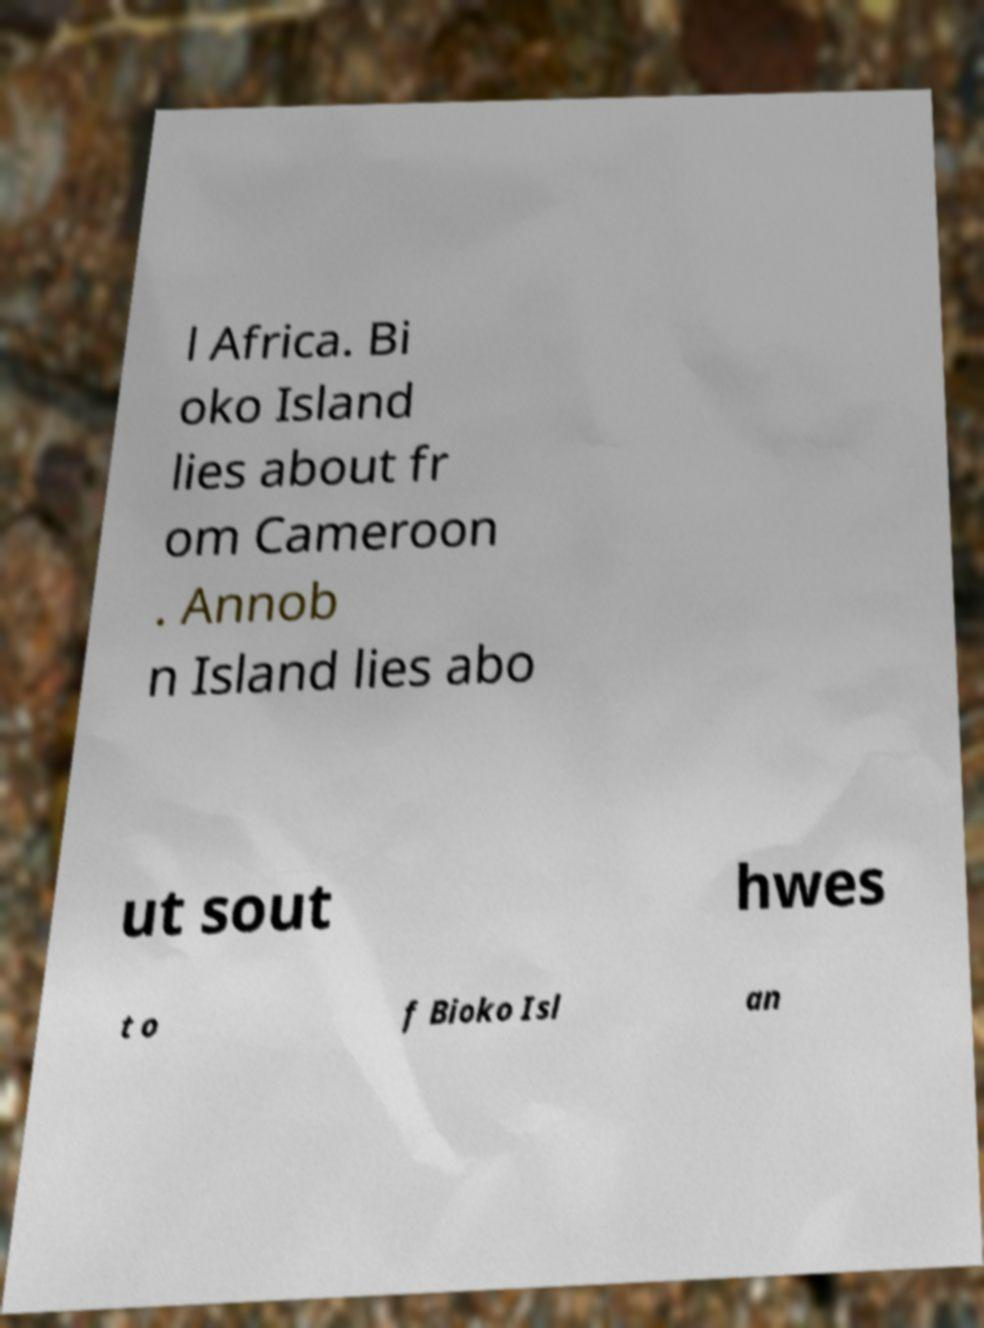There's text embedded in this image that I need extracted. Can you transcribe it verbatim? l Africa. Bi oko Island lies about fr om Cameroon . Annob n Island lies abo ut sout hwes t o f Bioko Isl an 